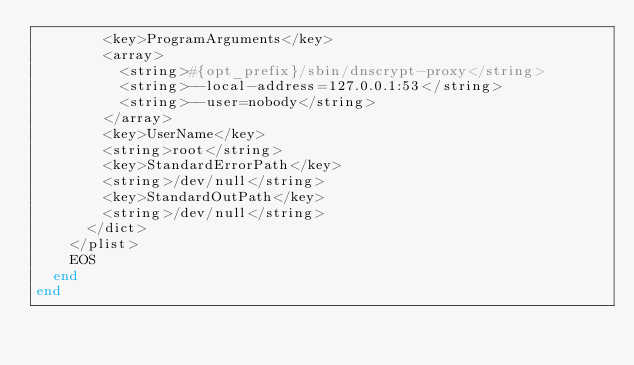<code> <loc_0><loc_0><loc_500><loc_500><_Ruby_>        <key>ProgramArguments</key>
        <array>
          <string>#{opt_prefix}/sbin/dnscrypt-proxy</string>
          <string>--local-address=127.0.0.1:53</string>
          <string>--user=nobody</string>
        </array>
        <key>UserName</key>
        <string>root</string>
        <key>StandardErrorPath</key>
        <string>/dev/null</string>
        <key>StandardOutPath</key>
        <string>/dev/null</string>
      </dict>
    </plist>
    EOS
  end
end
</code> 